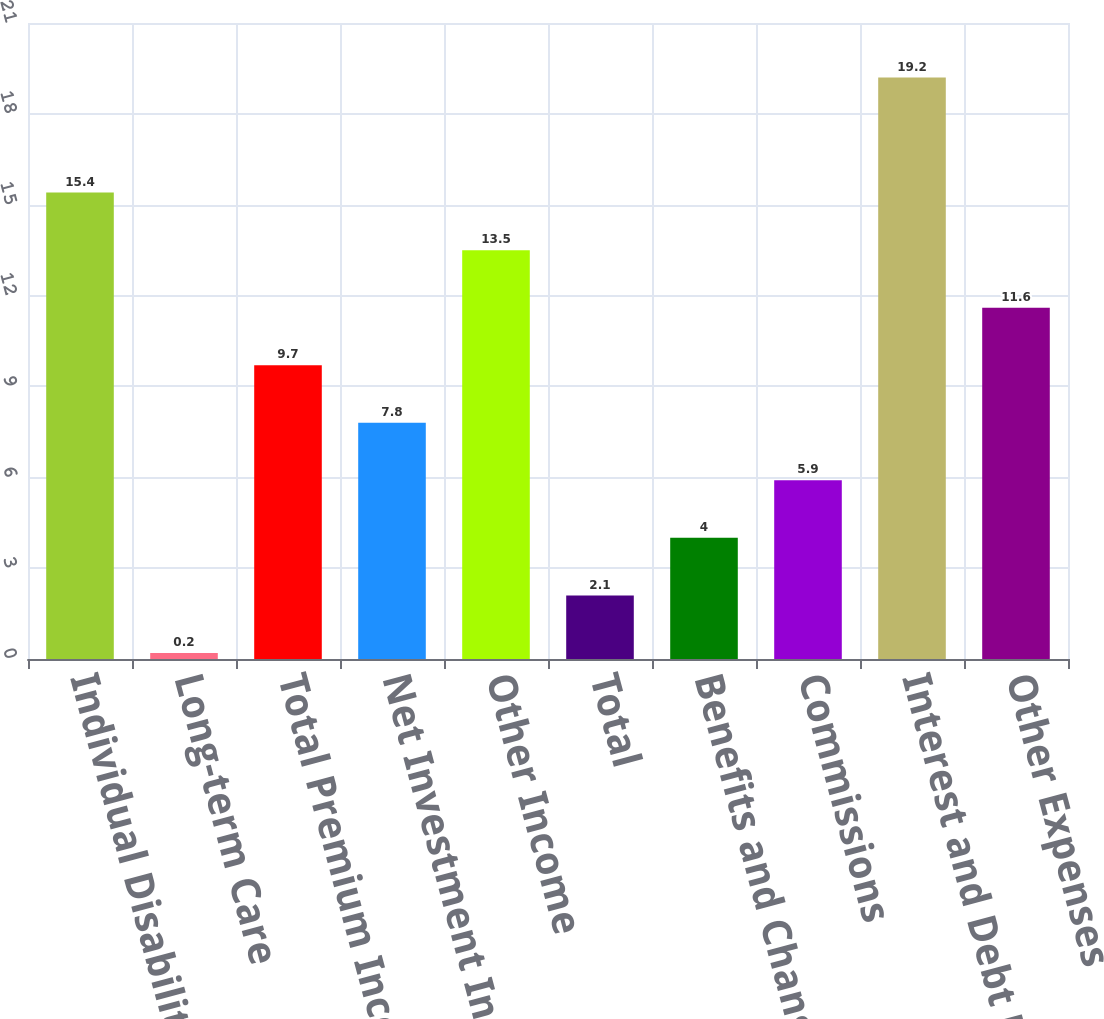Convert chart. <chart><loc_0><loc_0><loc_500><loc_500><bar_chart><fcel>Individual Disability<fcel>Long-term Care<fcel>Total Premium Income<fcel>Net Investment Income<fcel>Other Income<fcel>Total<fcel>Benefits and Change in<fcel>Commissions<fcel>Interest and Debt Expense<fcel>Other Expenses<nl><fcel>15.4<fcel>0.2<fcel>9.7<fcel>7.8<fcel>13.5<fcel>2.1<fcel>4<fcel>5.9<fcel>19.2<fcel>11.6<nl></chart> 